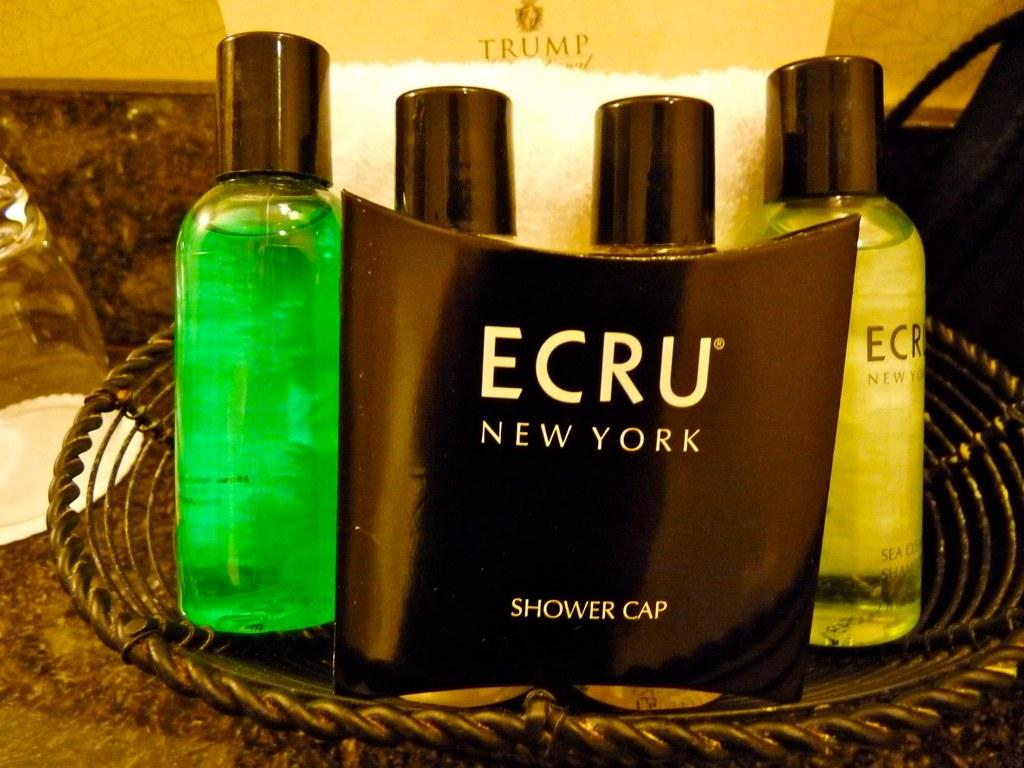<image>
Summarize the visual content of the image. Toiletries in a wire basket including a shower cap by Ecru New York 